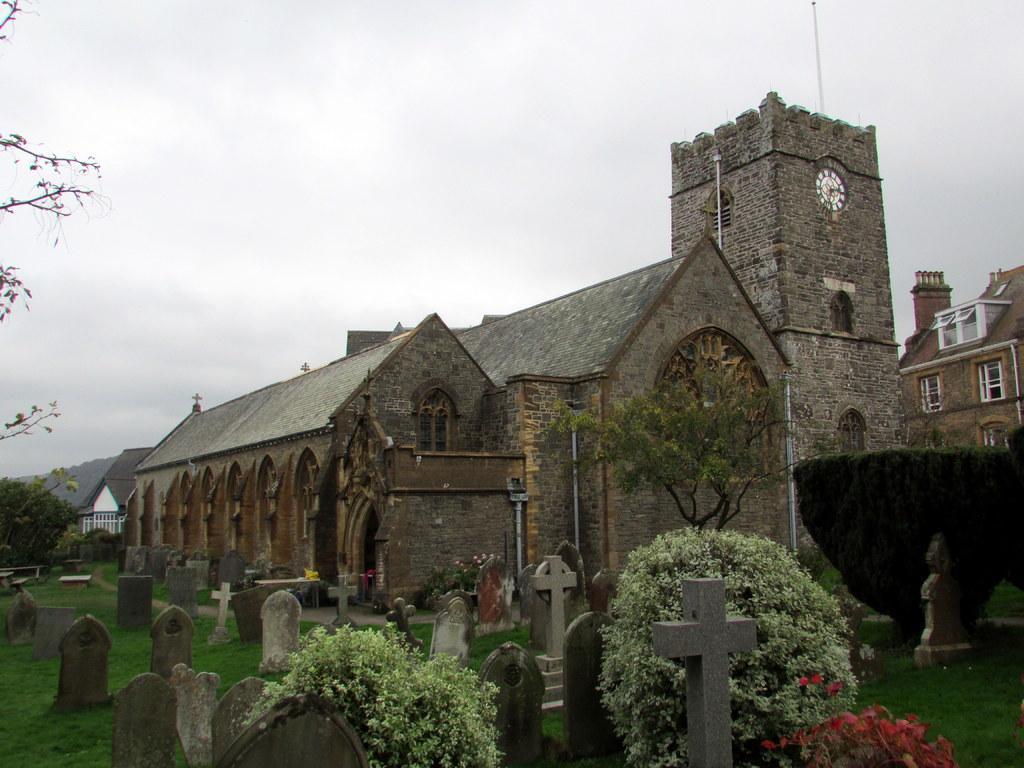Describe this image in one or two sentences. In this image I can see a cemetery and number of tombstones. I can see few trees, few flowers which are red in color, few buildings, a clock to the building and few pipes. In the background I can see the sky. 